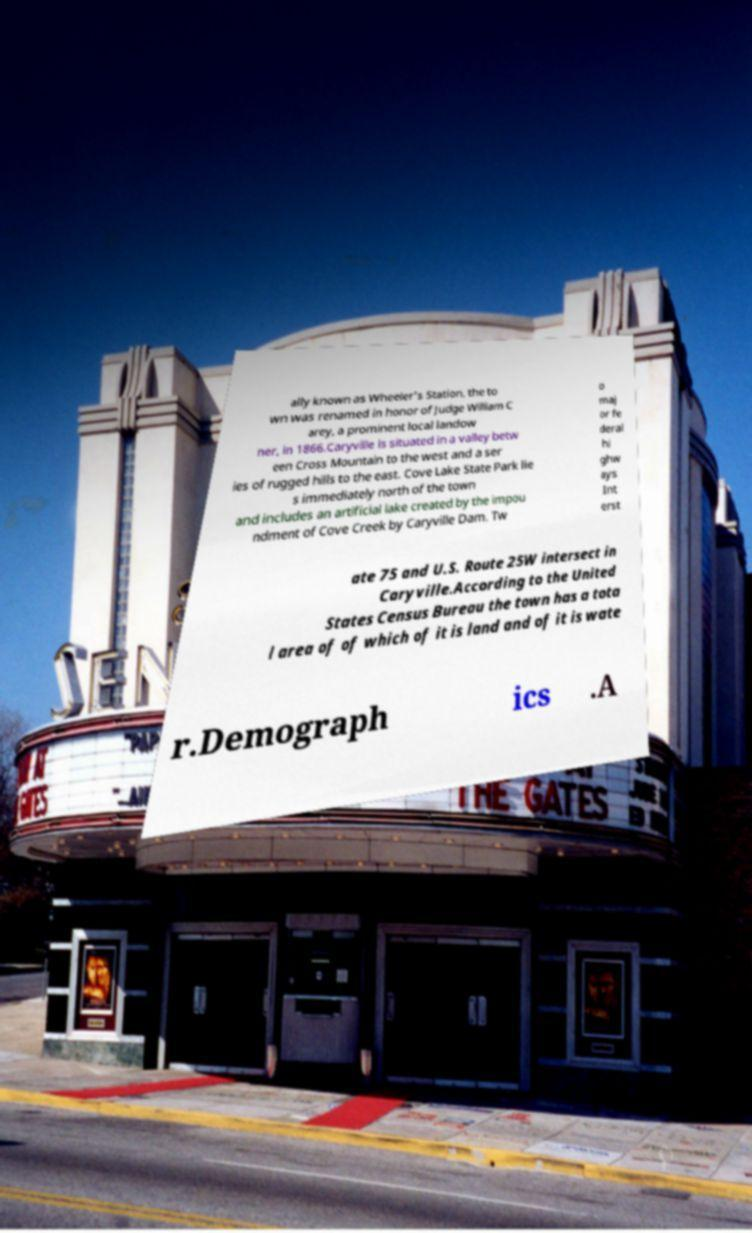There's text embedded in this image that I need extracted. Can you transcribe it verbatim? ally known as Wheeler's Station, the to wn was renamed in honor of Judge William C arey, a prominent local landow ner, in 1866.Caryville is situated in a valley betw een Cross Mountain to the west and a ser ies of rugged hills to the east. Cove Lake State Park lie s immediately north of the town and includes an artificial lake created by the impou ndment of Cove Creek by Caryville Dam. Tw o maj or fe deral hi ghw ays Int erst ate 75 and U.S. Route 25W intersect in Caryville.According to the United States Census Bureau the town has a tota l area of of which of it is land and of it is wate r.Demograph ics .A 